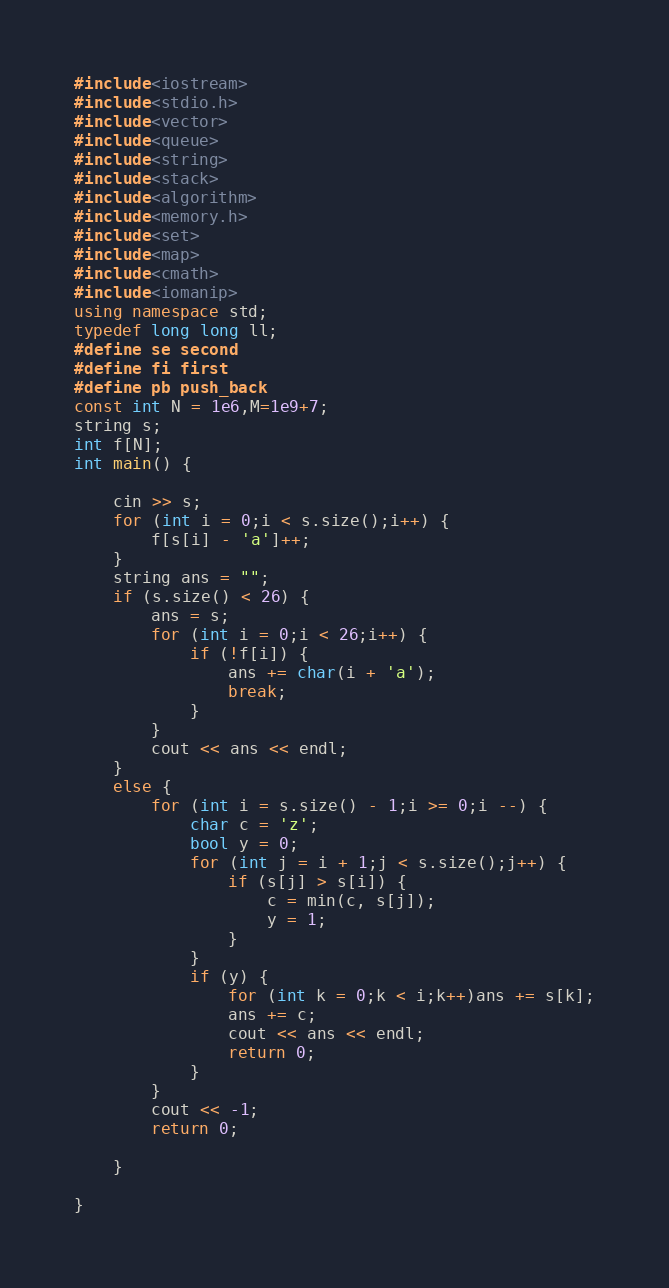<code> <loc_0><loc_0><loc_500><loc_500><_C++_>#include<iostream>
#include<stdio.h>
#include<vector>
#include<queue>
#include<string>
#include<stack>
#include<algorithm>
#include<memory.h>
#include<set>
#include<map>
#include<cmath>
#include<iomanip>
using namespace std;
typedef long long ll;
#define se second
#define fi first
#define pb push_back
const int N = 1e6,M=1e9+7;
string s;
int f[N];
int main() { 
	
	cin >> s;
	for (int i = 0;i < s.size();i++) {
		f[s[i] - 'a']++;
	}
	string ans = "";
	if (s.size() < 26) {
		ans = s;
		for (int i = 0;i < 26;i++) {
			if (!f[i]) {
				ans += char(i + 'a');
				break;
			}
		}
		cout << ans << endl;
	}
	else {
		for (int i = s.size() - 1;i >= 0;i --) {
			char c = 'z';
			bool y = 0;
			for (int j = i + 1;j < s.size();j++) {
				if (s[j] > s[i]) {
					c = min(c, s[j]);
					y = 1;
				}
			}
			if (y) {
				for (int k = 0;k < i;k++)ans += s[k];
				ans += c;
				cout << ans << endl;
				return 0;
			}
		}
		cout << -1;
		return 0;

	}

}
</code> 